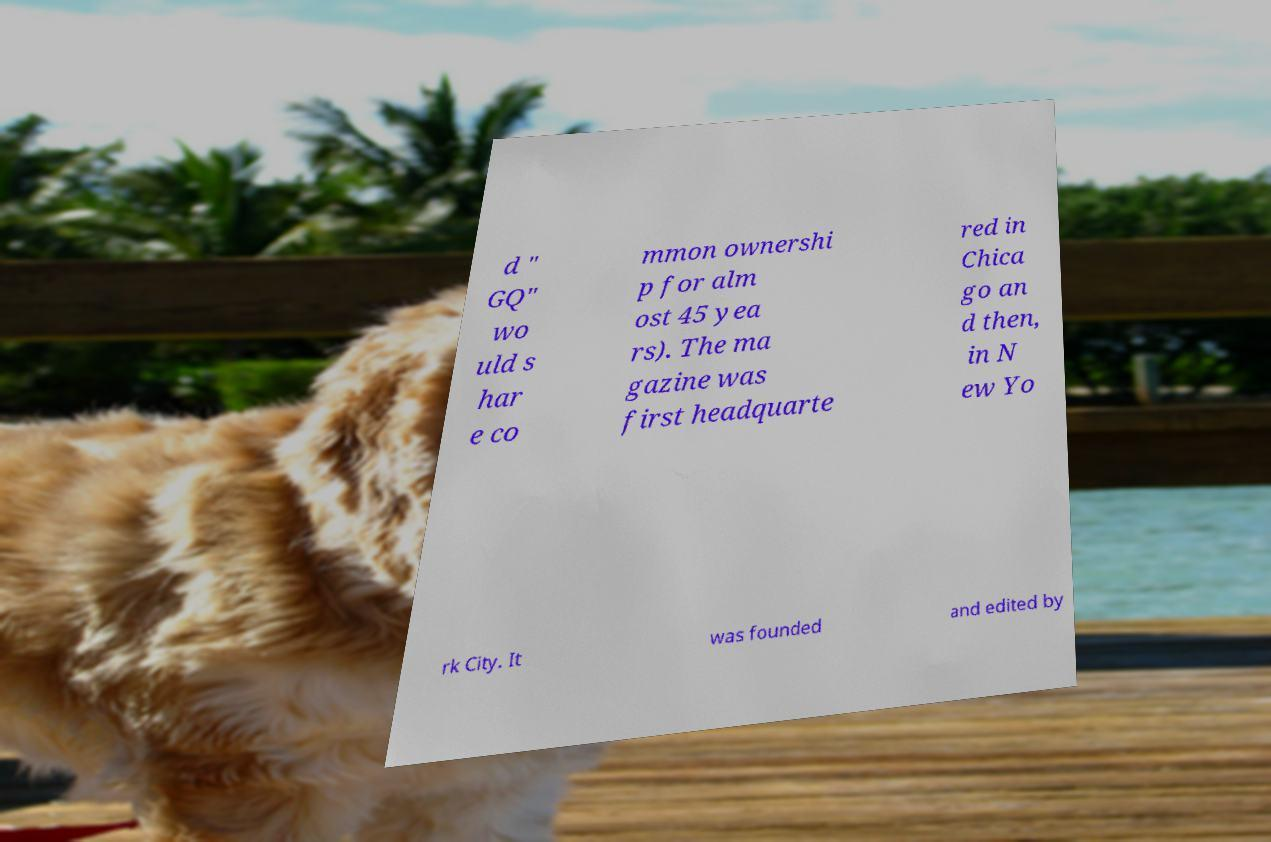Could you extract and type out the text from this image? d " GQ" wo uld s har e co mmon ownershi p for alm ost 45 yea rs). The ma gazine was first headquarte red in Chica go an d then, in N ew Yo rk City. It was founded and edited by 